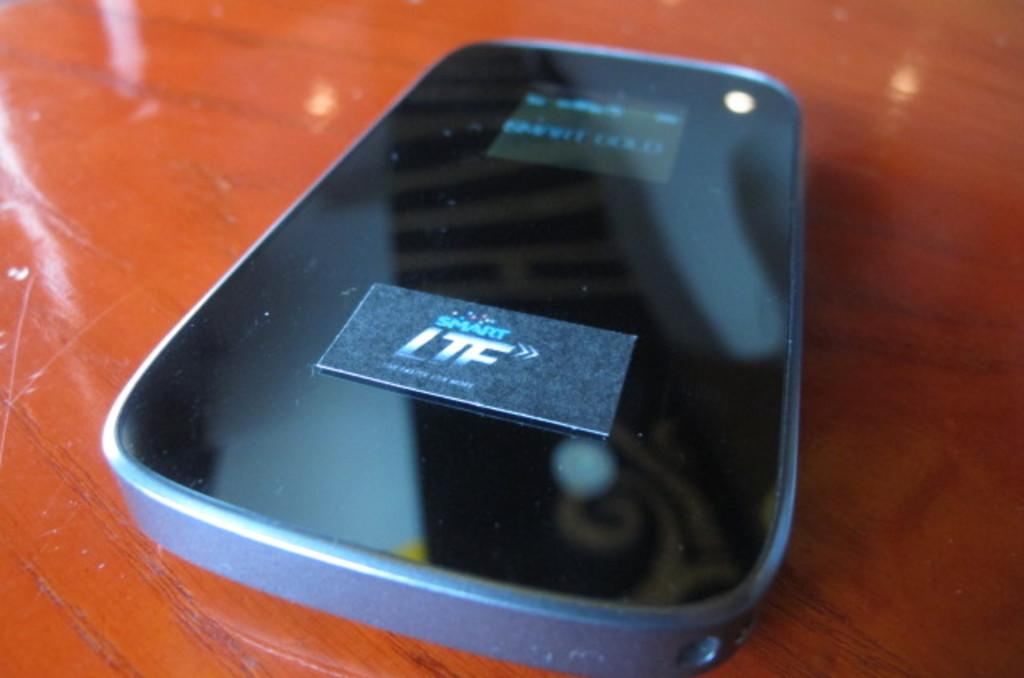<image>
Share a concise interpretation of the image provided. a cell phone with the letters LTF on the bottom 